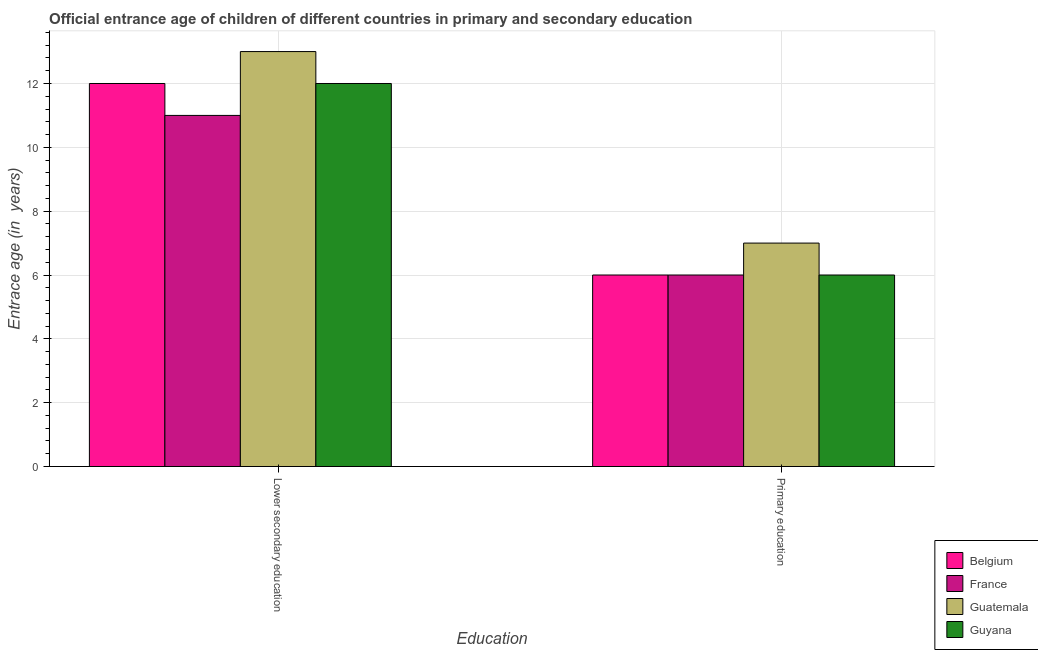How many different coloured bars are there?
Your answer should be compact. 4. How many groups of bars are there?
Provide a short and direct response. 2. Are the number of bars on each tick of the X-axis equal?
Provide a short and direct response. Yes. Across all countries, what is the maximum entrance age of children in lower secondary education?
Make the answer very short. 13. Across all countries, what is the minimum entrance age of chiildren in primary education?
Provide a short and direct response. 6. In which country was the entrance age of chiildren in primary education maximum?
Ensure brevity in your answer.  Guatemala. In which country was the entrance age of children in lower secondary education minimum?
Provide a short and direct response. France. What is the total entrance age of children in lower secondary education in the graph?
Provide a short and direct response. 48. What is the difference between the entrance age of children in lower secondary education in France and that in Belgium?
Offer a very short reply. -1. What is the difference between the entrance age of chiildren in primary education in Guatemala and the entrance age of children in lower secondary education in Belgium?
Your response must be concise. -5. What is the average entrance age of children in lower secondary education per country?
Keep it short and to the point. 12. What is the difference between the entrance age of children in lower secondary education and entrance age of chiildren in primary education in Guyana?
Your answer should be very brief. 6. In how many countries, is the entrance age of children in lower secondary education greater than 13.2 years?
Give a very brief answer. 0. What is the ratio of the entrance age of children in lower secondary education in Guatemala to that in Belgium?
Your answer should be very brief. 1.08. In how many countries, is the entrance age of children in lower secondary education greater than the average entrance age of children in lower secondary education taken over all countries?
Offer a terse response. 1. What does the 3rd bar from the left in Lower secondary education represents?
Your response must be concise. Guatemala. How many bars are there?
Offer a terse response. 8. Are the values on the major ticks of Y-axis written in scientific E-notation?
Ensure brevity in your answer.  No. Does the graph contain grids?
Give a very brief answer. Yes. Where does the legend appear in the graph?
Provide a short and direct response. Bottom right. What is the title of the graph?
Offer a very short reply. Official entrance age of children of different countries in primary and secondary education. Does "Puerto Rico" appear as one of the legend labels in the graph?
Provide a short and direct response. No. What is the label or title of the X-axis?
Your response must be concise. Education. What is the label or title of the Y-axis?
Keep it short and to the point. Entrace age (in  years). What is the Entrace age (in  years) of Belgium in Lower secondary education?
Your answer should be compact. 12. What is the Entrace age (in  years) of France in Lower secondary education?
Provide a short and direct response. 11. What is the Entrace age (in  years) of Guyana in Lower secondary education?
Provide a short and direct response. 12. Across all Education, what is the maximum Entrace age (in  years) of Guyana?
Make the answer very short. 12. Across all Education, what is the minimum Entrace age (in  years) of France?
Ensure brevity in your answer.  6. Across all Education, what is the minimum Entrace age (in  years) in Guatemala?
Your response must be concise. 7. Across all Education, what is the minimum Entrace age (in  years) of Guyana?
Your answer should be very brief. 6. What is the total Entrace age (in  years) in Belgium in the graph?
Ensure brevity in your answer.  18. What is the total Entrace age (in  years) in Guyana in the graph?
Ensure brevity in your answer.  18. What is the difference between the Entrace age (in  years) of Belgium in Lower secondary education and that in Primary education?
Give a very brief answer. 6. What is the difference between the Entrace age (in  years) in Belgium in Lower secondary education and the Entrace age (in  years) in Guatemala in Primary education?
Provide a succinct answer. 5. What is the difference between the Entrace age (in  years) in Belgium in Lower secondary education and the Entrace age (in  years) in Guyana in Primary education?
Ensure brevity in your answer.  6. What is the difference between the Entrace age (in  years) of France in Lower secondary education and the Entrace age (in  years) of Guyana in Primary education?
Keep it short and to the point. 5. What is the difference between the Entrace age (in  years) in Guatemala in Lower secondary education and the Entrace age (in  years) in Guyana in Primary education?
Provide a succinct answer. 7. What is the average Entrace age (in  years) of Guyana per Education?
Provide a succinct answer. 9. What is the difference between the Entrace age (in  years) in Belgium and Entrace age (in  years) in France in Lower secondary education?
Keep it short and to the point. 1. What is the difference between the Entrace age (in  years) of Belgium and Entrace age (in  years) of Guyana in Lower secondary education?
Keep it short and to the point. 0. What is the difference between the Entrace age (in  years) of France and Entrace age (in  years) of Guyana in Lower secondary education?
Your response must be concise. -1. What is the difference between the Entrace age (in  years) of Guatemala and Entrace age (in  years) of Guyana in Lower secondary education?
Your answer should be very brief. 1. What is the difference between the Entrace age (in  years) of Belgium and Entrace age (in  years) of France in Primary education?
Your answer should be very brief. 0. What is the difference between the Entrace age (in  years) in Belgium and Entrace age (in  years) in Guatemala in Primary education?
Ensure brevity in your answer.  -1. What is the difference between the Entrace age (in  years) in Belgium and Entrace age (in  years) in Guyana in Primary education?
Offer a terse response. 0. What is the difference between the Entrace age (in  years) of France and Entrace age (in  years) of Guyana in Primary education?
Give a very brief answer. 0. What is the ratio of the Entrace age (in  years) of Belgium in Lower secondary education to that in Primary education?
Your response must be concise. 2. What is the ratio of the Entrace age (in  years) in France in Lower secondary education to that in Primary education?
Give a very brief answer. 1.83. What is the ratio of the Entrace age (in  years) of Guatemala in Lower secondary education to that in Primary education?
Your response must be concise. 1.86. What is the ratio of the Entrace age (in  years) of Guyana in Lower secondary education to that in Primary education?
Make the answer very short. 2. What is the difference between the highest and the second highest Entrace age (in  years) of Guatemala?
Provide a succinct answer. 6. 